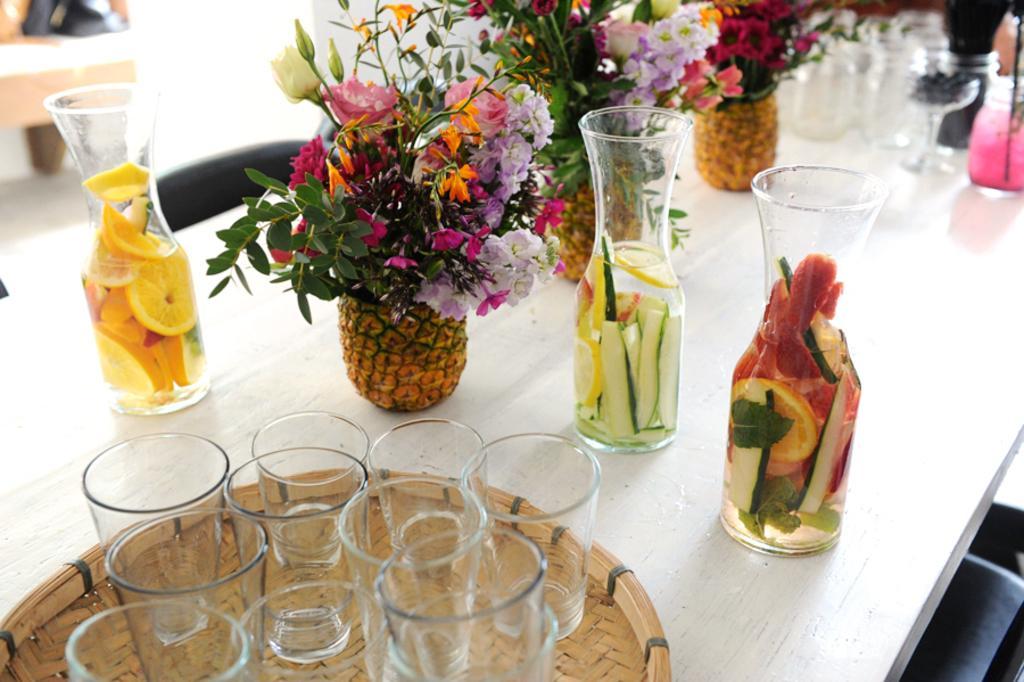How would you summarize this image in a sentence or two? In this picture I can see pine apples with flowers, there are glass jars with vegetables and fruits slices in it, there are glasses on the tray, and there are some other items on the table, and in the background there are some objects. 